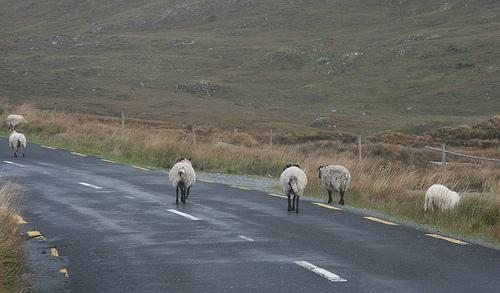Question: how many sheep are there?
Choices:
A. 6.
B. 5.
C. 7.
D. 8.
Answer with the letter. Answer: A Question: where are the sheep located?
Choices:
A. At the zoo.
B. On top of the hill.
C. The farm.
D. On the road.
Answer with the letter. Answer: D Question: what color are the sheep?
Choices:
A. Black and white.
B. Black and brown.
C. White and gray.
D. Gray and brown.
Answer with the letter. Answer: A Question: where is the fence line?
Choices:
A. Next to the road.
B. By the cows.
C. By the sidewalk.
D. By the flowers.
Answer with the letter. Answer: A Question: how many black and white sheep are there?
Choices:
A. 3.
B. 2.
C. 4.
D. 5.
Answer with the letter. Answer: A 